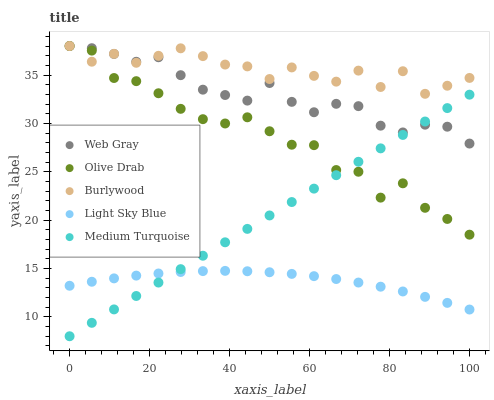Does Light Sky Blue have the minimum area under the curve?
Answer yes or no. Yes. Does Burlywood have the maximum area under the curve?
Answer yes or no. Yes. Does Web Gray have the minimum area under the curve?
Answer yes or no. No. Does Web Gray have the maximum area under the curve?
Answer yes or no. No. Is Medium Turquoise the smoothest?
Answer yes or no. Yes. Is Olive Drab the roughest?
Answer yes or no. Yes. Is Web Gray the smoothest?
Answer yes or no. No. Is Web Gray the roughest?
Answer yes or no. No. Does Medium Turquoise have the lowest value?
Answer yes or no. Yes. Does Web Gray have the lowest value?
Answer yes or no. No. Does Olive Drab have the highest value?
Answer yes or no. Yes. Does Medium Turquoise have the highest value?
Answer yes or no. No. Is Light Sky Blue less than Web Gray?
Answer yes or no. Yes. Is Burlywood greater than Medium Turquoise?
Answer yes or no. Yes. Does Burlywood intersect Web Gray?
Answer yes or no. Yes. Is Burlywood less than Web Gray?
Answer yes or no. No. Is Burlywood greater than Web Gray?
Answer yes or no. No. Does Light Sky Blue intersect Web Gray?
Answer yes or no. No. 